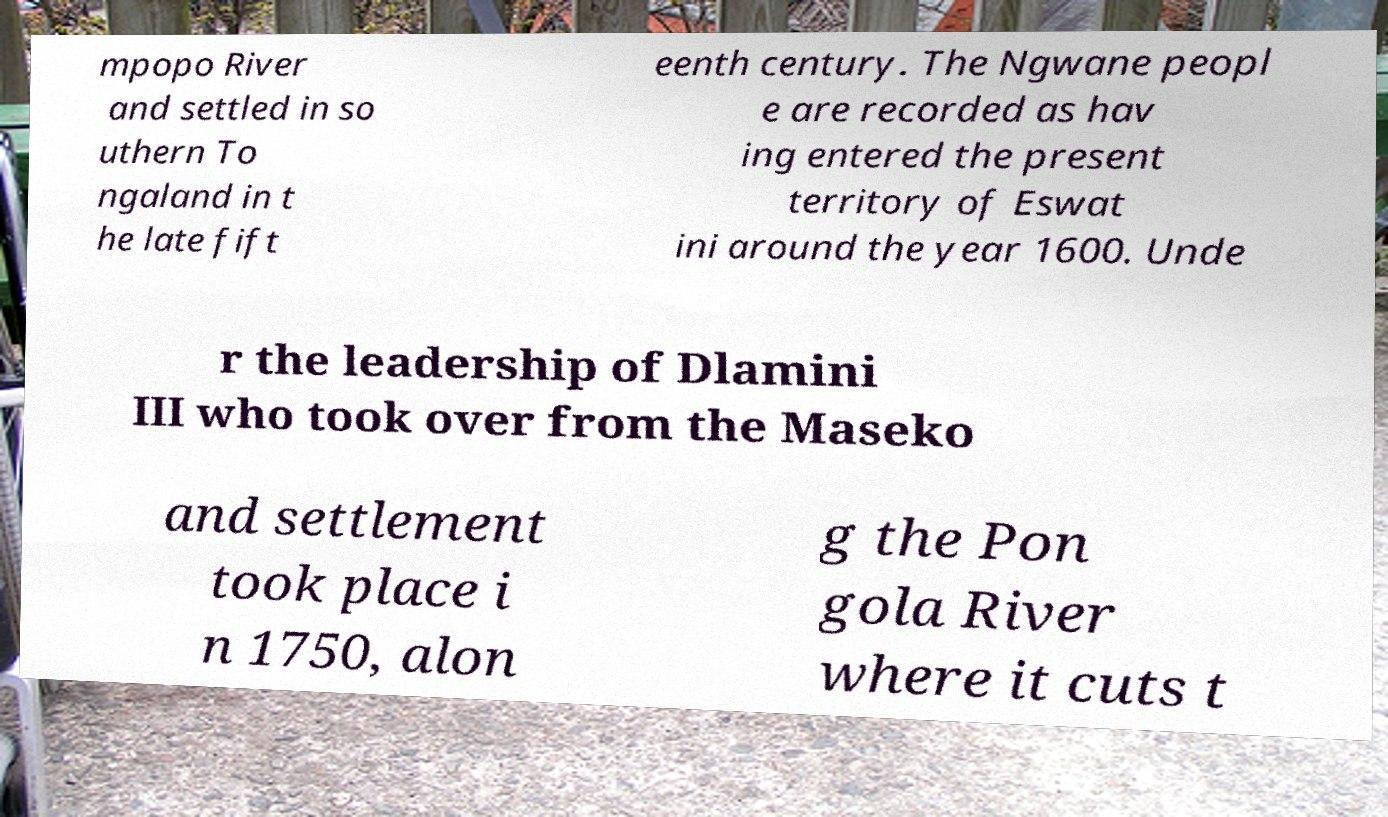What messages or text are displayed in this image? I need them in a readable, typed format. mpopo River and settled in so uthern To ngaland in t he late fift eenth century. The Ngwane peopl e are recorded as hav ing entered the present territory of Eswat ini around the year 1600. Unde r the leadership of Dlamini III who took over from the Maseko and settlement took place i n 1750, alon g the Pon gola River where it cuts t 